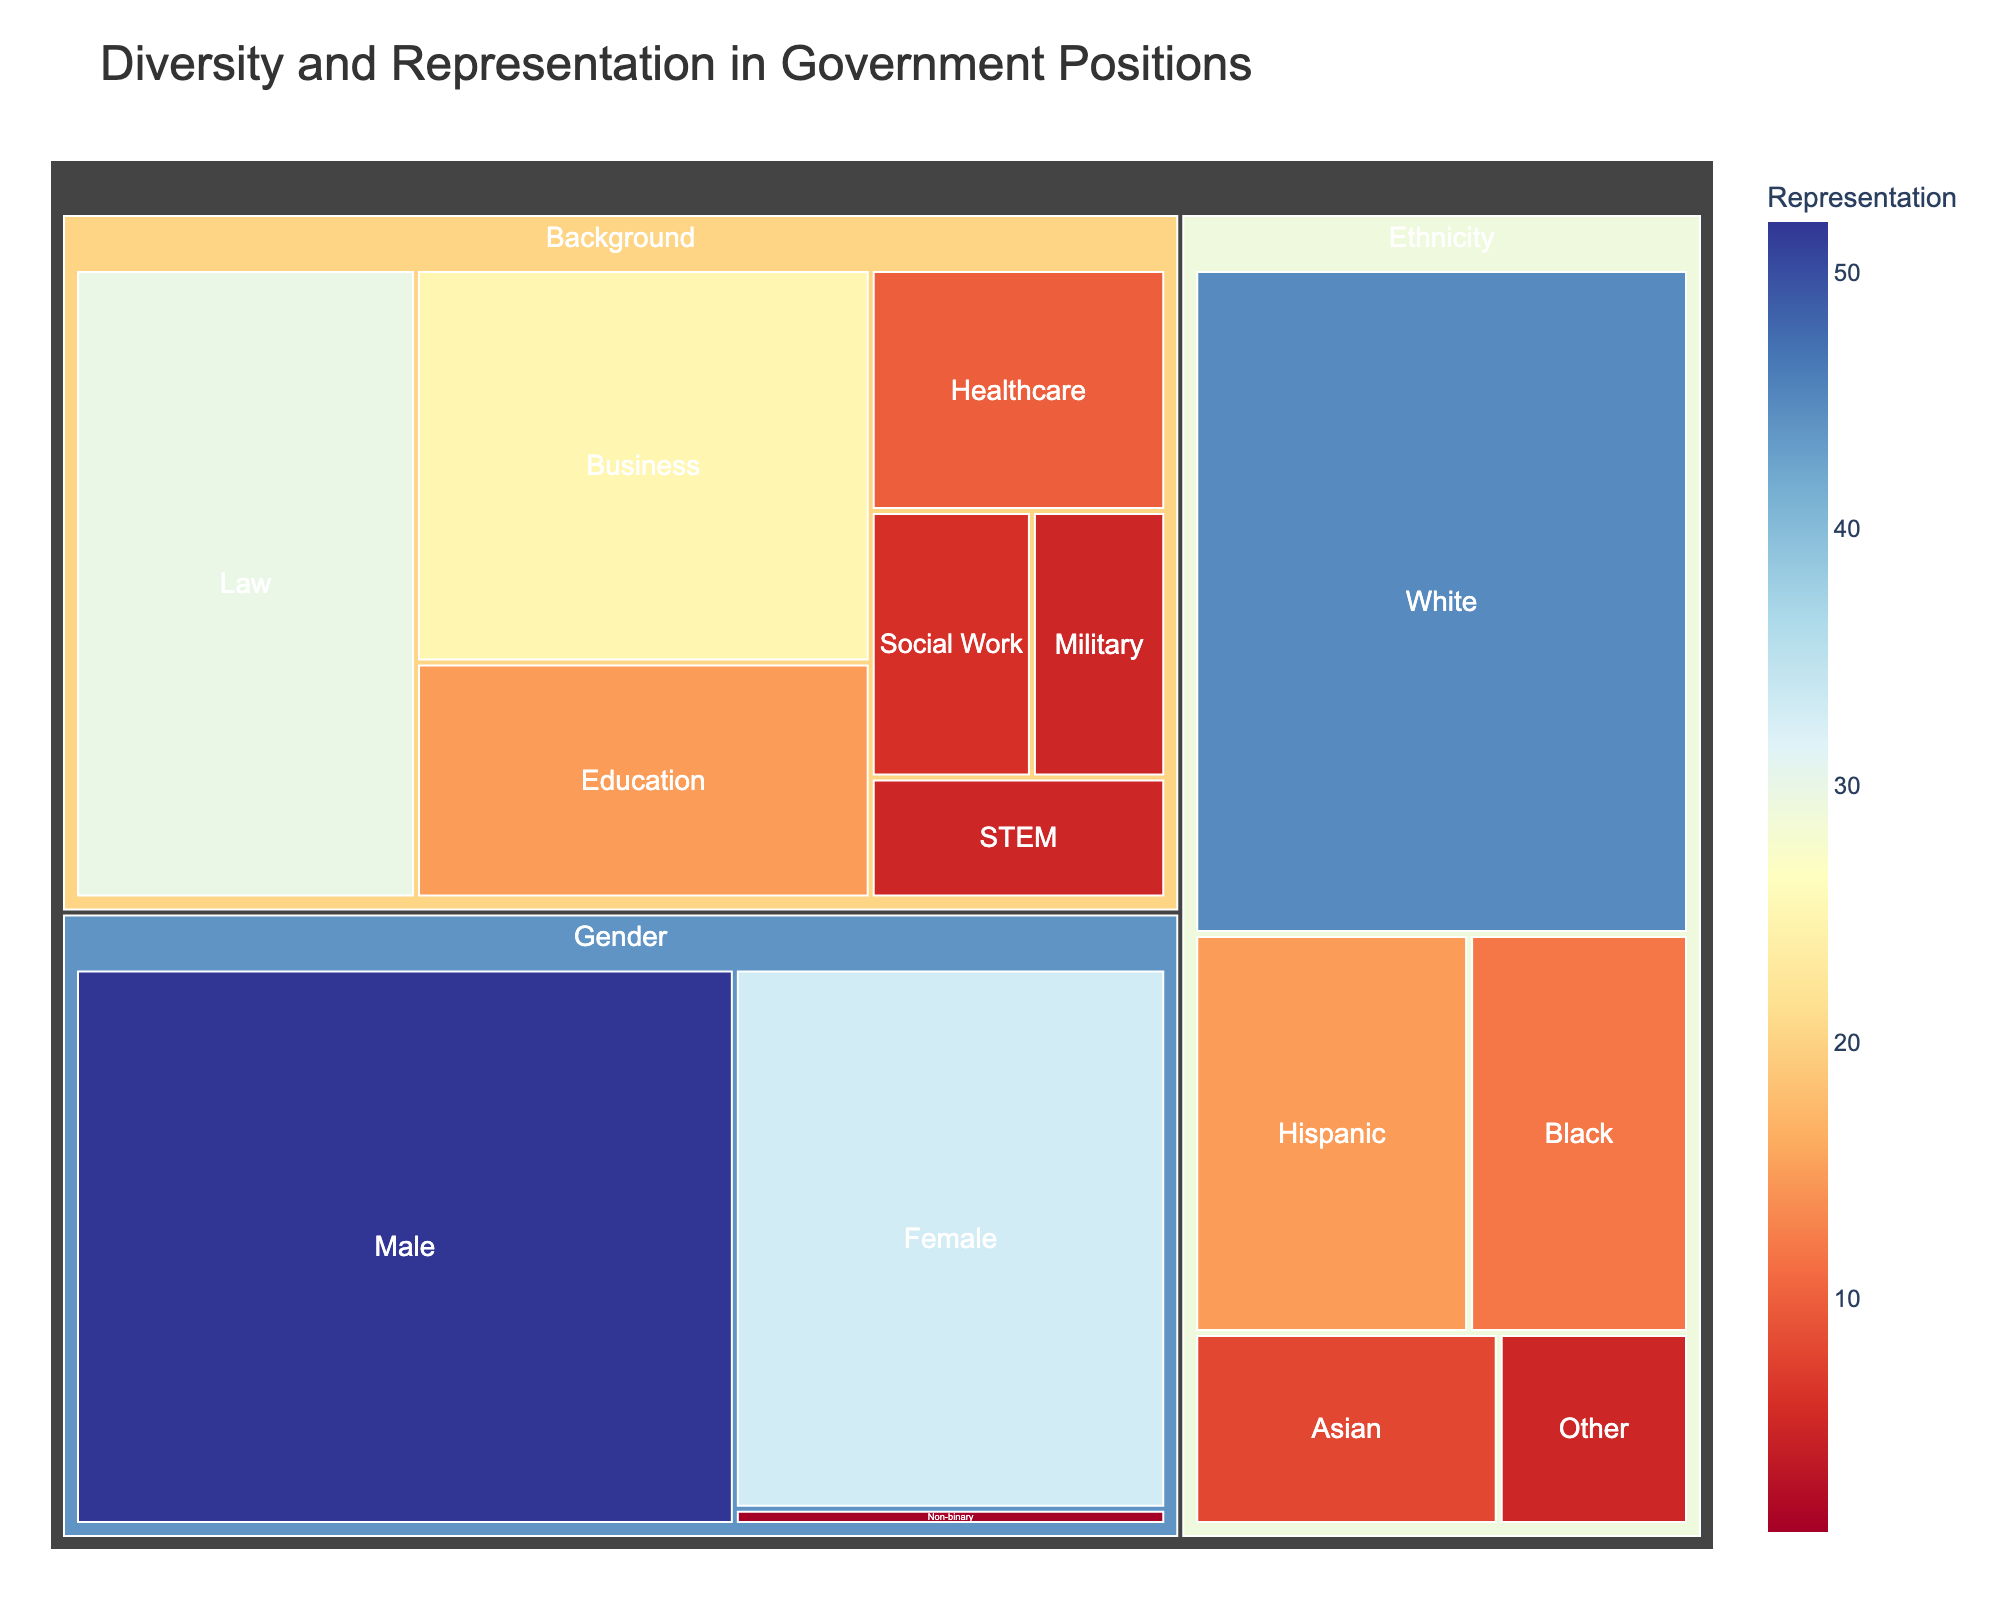What is the largest represented ethnicity in government positions? The largest represented ethnicity can be determined by looking at the sections under the 'Ethnicity' category with the highest value. The segment for 'White' is the largest.
Answer: White How many more males are represented than females in government positions? To find the difference, subtract the value for 'Female' from the value for 'Male'. The value for 'Male' is 52 and for 'Female' is 33. Thus, the difference is 52 - 33.
Answer: 19 What is the category with the least representation value? By comparing the smallest values under each category, 'Gender' under 'Non-binary' has the smallest value of 1.
Answer: Gender (Non-binary) What is the combined representation percentage for the 'Black' and 'Asian' ethnicities? Add the values for 'Black' and 'Asian': 12 (Black) + 8 (Asian) = 20. To get the percentage, divide this combined value by the total for 'Ethnicity'. The total is 45 (White) + 15 (Hispanic) + 12 (Black) + 8 (Asian) + 5 (Other) = 85. So, (20/85) * 100.
Answer: 23.5% Which background has a higher representation: 'Healthcare' or 'STEM'? Compare the values for the 'Healthcare' and 'STEM' subcategories. 'Healthcare' has 10 and 'STEM' has 5.
Answer: Healthcare How many subcategories are there under the 'Background' category? Count the number of distinct entries under 'Background'. There are 'Law', 'Business', 'Education', 'Healthcare', 'Social Work', 'Military', and 'STEM' which total to 7.
Answer: 7 Among the 'Female' and 'Non-binary' genders, which has a lower representation value? Compare the values for 'Female' and 'Non-binary'. 'Female' has 33 and 'Non-binary' has 1.
Answer: Non-binary What is the average value of representation in the 'Background' category? To find the average, sum all the values and divide by the number of subcategories. The sum is 30 (Law) + 25 (Business) + 15 (Education) + 10 (Healthcare) + 6 (Social Work) + 5 (Military) + 5 (STEM) = 96. The number of subcategories is 7. So, 96/7.
Answer: 13.7 